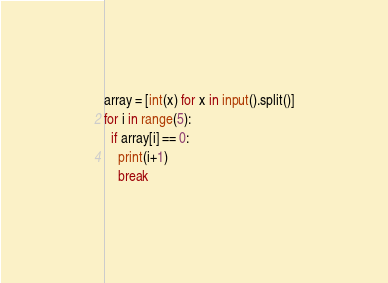<code> <loc_0><loc_0><loc_500><loc_500><_Python_>array = [int(x) for x in input().split()]
for i in range(5):
  if array[i] == 0:
    print(i+1)
    break</code> 